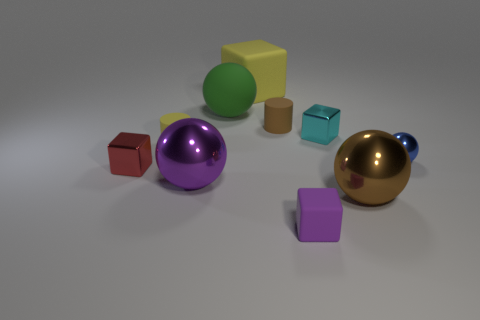Subtract all small spheres. How many spheres are left? 3 Subtract 2 cylinders. How many cylinders are left? 0 Subtract all blue spheres. How many spheres are left? 3 Add 8 tiny purple rubber spheres. How many tiny purple rubber spheres exist? 8 Subtract 0 gray cubes. How many objects are left? 10 Subtract all cylinders. How many objects are left? 8 Subtract all brown cylinders. Subtract all purple cubes. How many cylinders are left? 1 Subtract all brown spheres. How many green cylinders are left? 0 Subtract all big yellow matte objects. Subtract all big purple metallic objects. How many objects are left? 8 Add 6 tiny red shiny blocks. How many tiny red shiny blocks are left? 7 